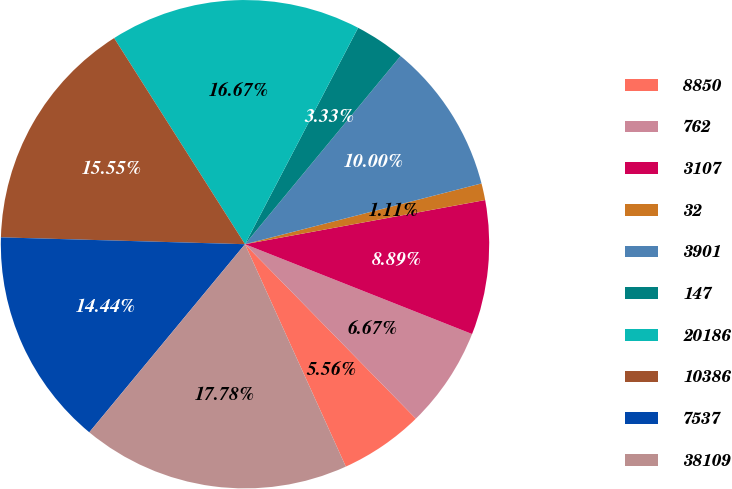Convert chart. <chart><loc_0><loc_0><loc_500><loc_500><pie_chart><fcel>8850<fcel>762<fcel>3107<fcel>32<fcel>3901<fcel>147<fcel>20186<fcel>10386<fcel>7537<fcel>38109<nl><fcel>5.56%<fcel>6.67%<fcel>8.89%<fcel>1.11%<fcel>10.0%<fcel>3.33%<fcel>16.67%<fcel>15.55%<fcel>14.44%<fcel>17.78%<nl></chart> 